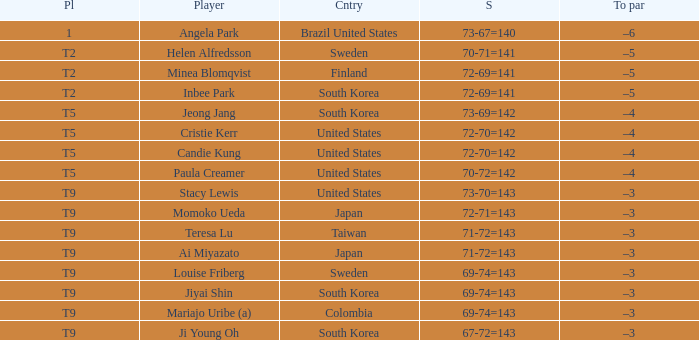Who scored 69-74=143 for Colombia? Mariajo Uribe (a). 